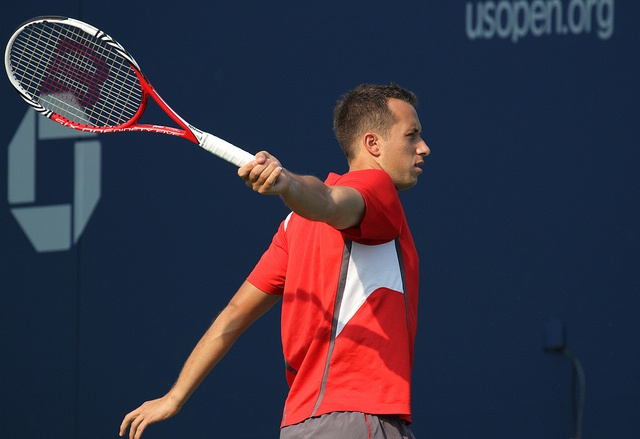Describe the objects in this image and their specific colors. I can see people in black, red, and maroon tones and tennis racket in black, gray, white, and navy tones in this image. 